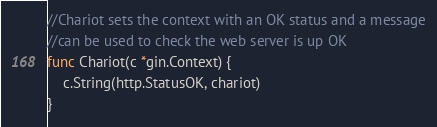<code> <loc_0><loc_0><loc_500><loc_500><_Go_>//Chariot sets the context with an OK status and a message
//can be used to check the web server is up OK
func Chariot(c *gin.Context) {
	c.String(http.StatusOK, chariot)
}
</code> 